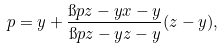Convert formula to latex. <formula><loc_0><loc_0><loc_500><loc_500>p = y + \frac { \i p { z - y } { x - y } } { \i p { z - y } { z - y } } ( z - y ) ,</formula> 